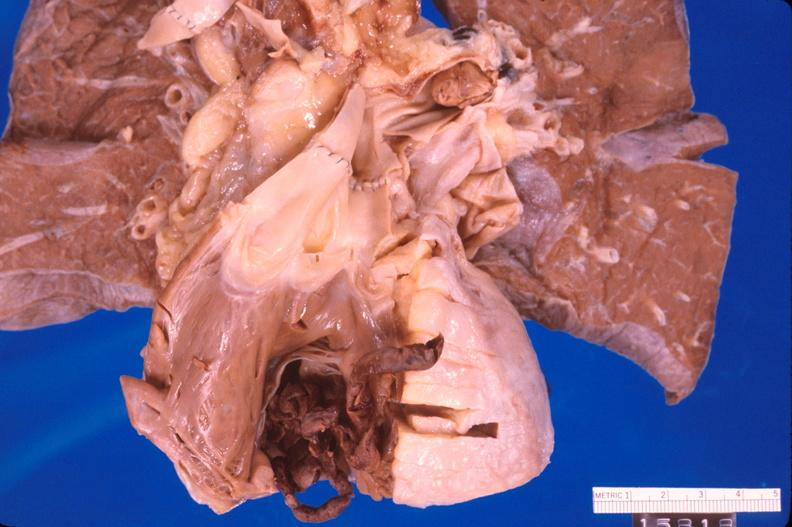what is present?
Answer the question using a single word or phrase. Heart 